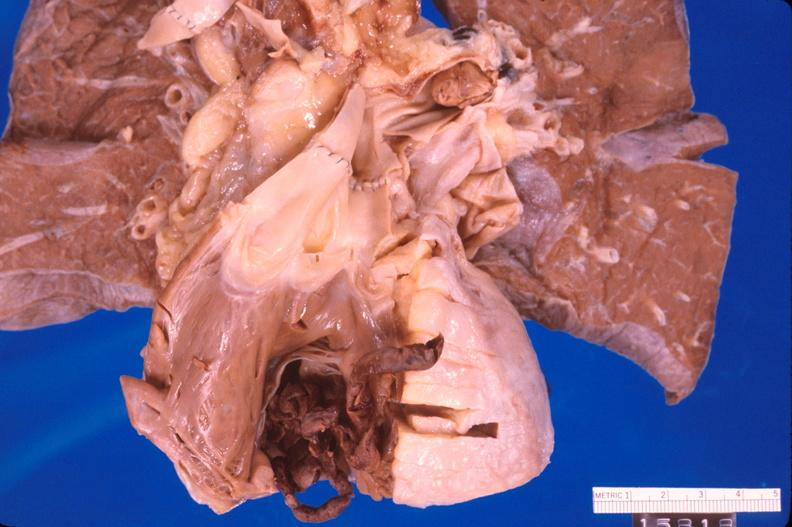what is present?
Answer the question using a single word or phrase. Heart 